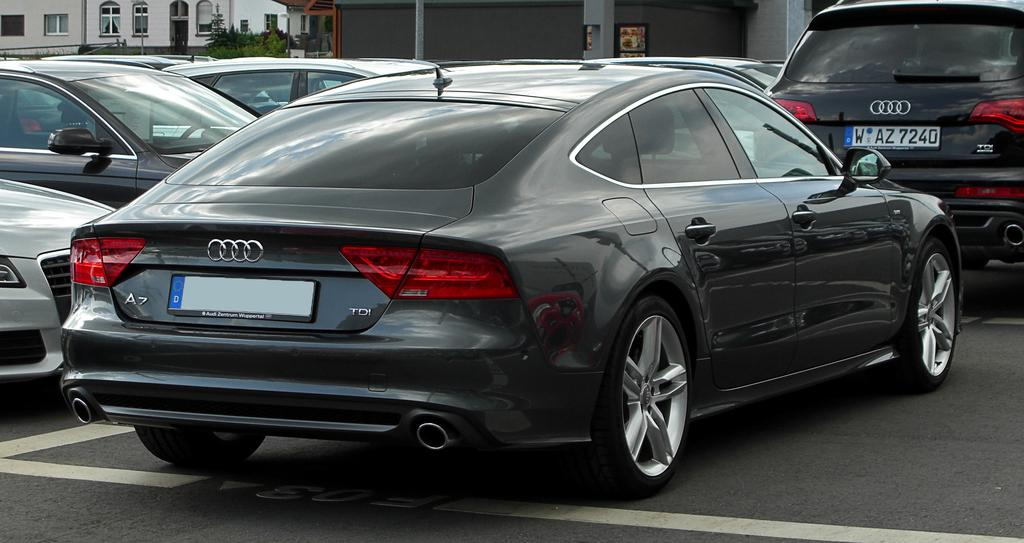Provide a one-sentence caption for the provided image. A black Audi sedan is behind an Audi SUV, with the license plate WAZ7240. 